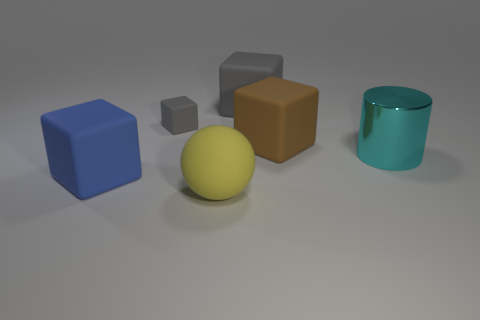Subtract 2 cubes. How many cubes are left? 2 Subtract all brown cubes. How many cubes are left? 3 Subtract all large blue matte cubes. How many cubes are left? 3 Subtract all red blocks. Subtract all green cylinders. How many blocks are left? 4 Add 1 large red matte cylinders. How many objects exist? 7 Subtract all cubes. How many objects are left? 2 Subtract all big gray blocks. Subtract all big yellow rubber things. How many objects are left? 4 Add 2 balls. How many balls are left? 3 Add 6 big blue cubes. How many big blue cubes exist? 7 Subtract 0 purple balls. How many objects are left? 6 